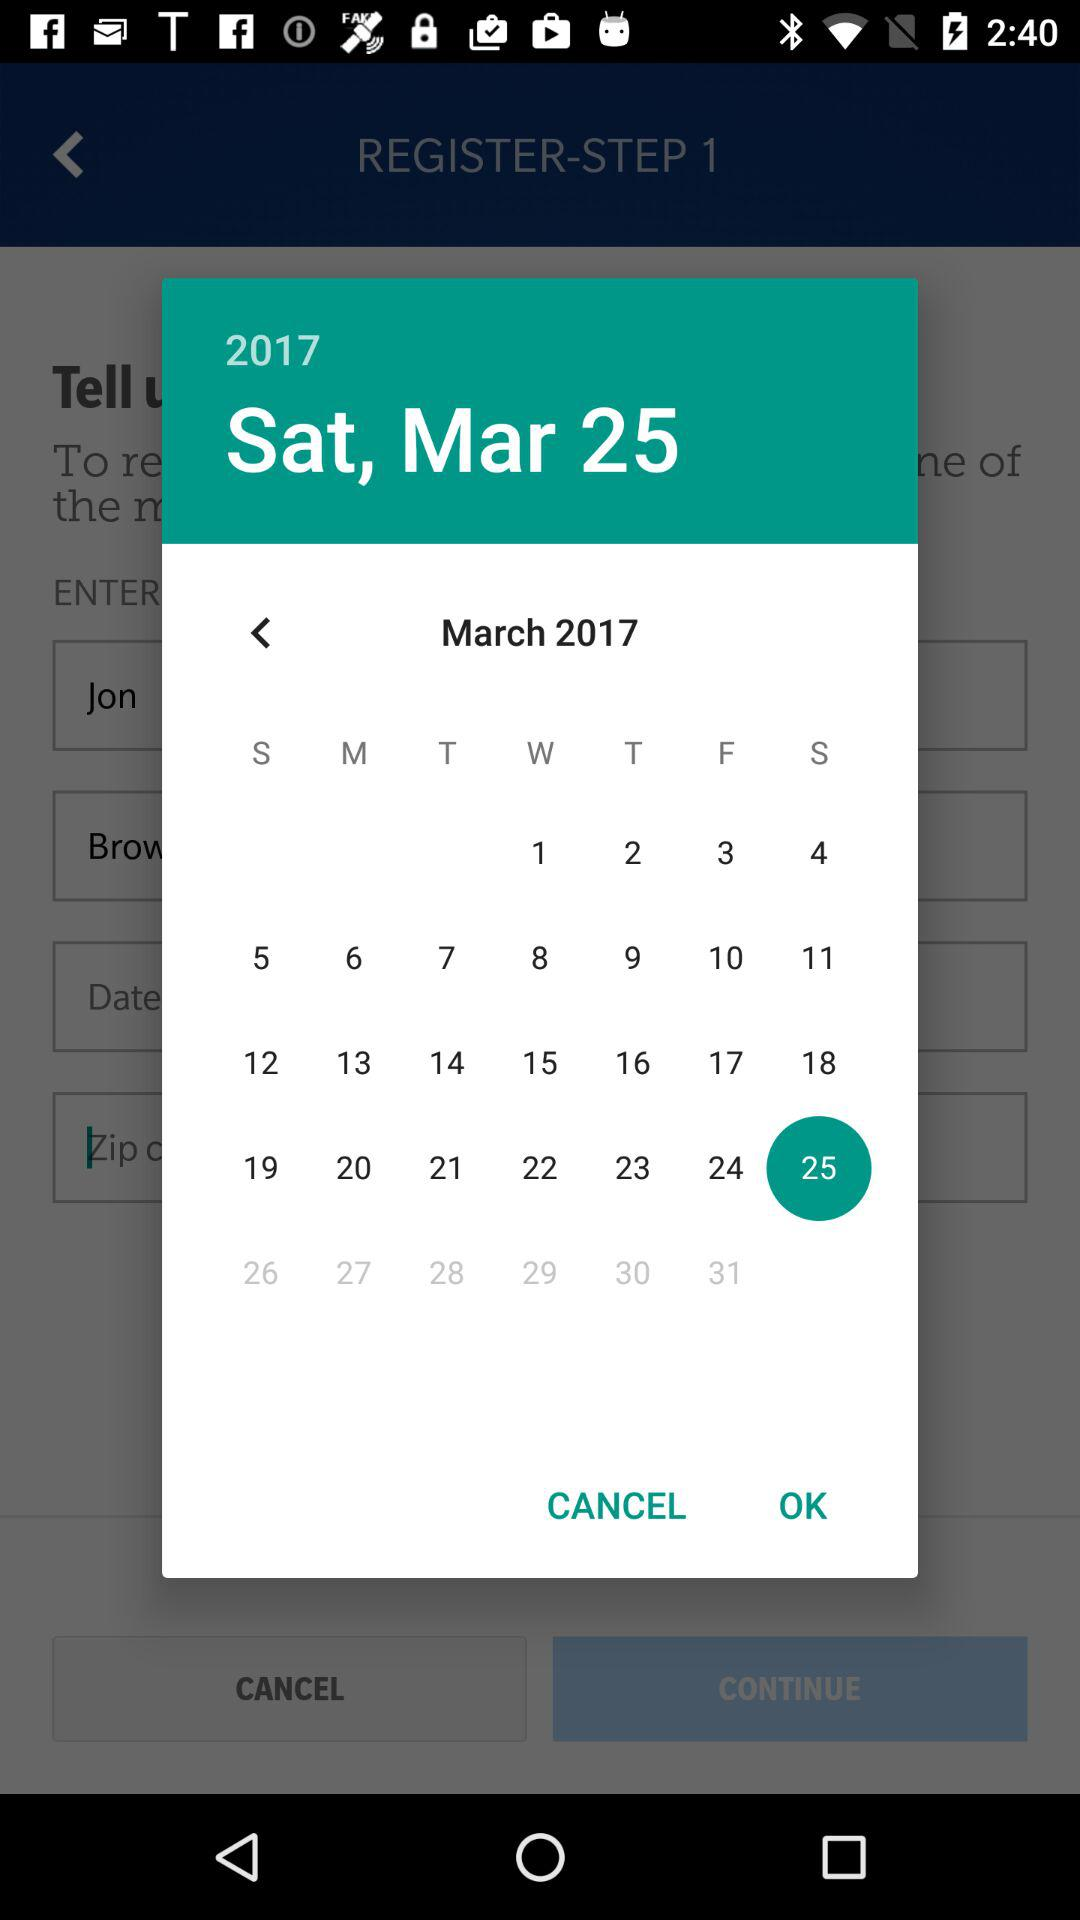What is the selected date? The selected date is Saturday, March 25, 2017. 